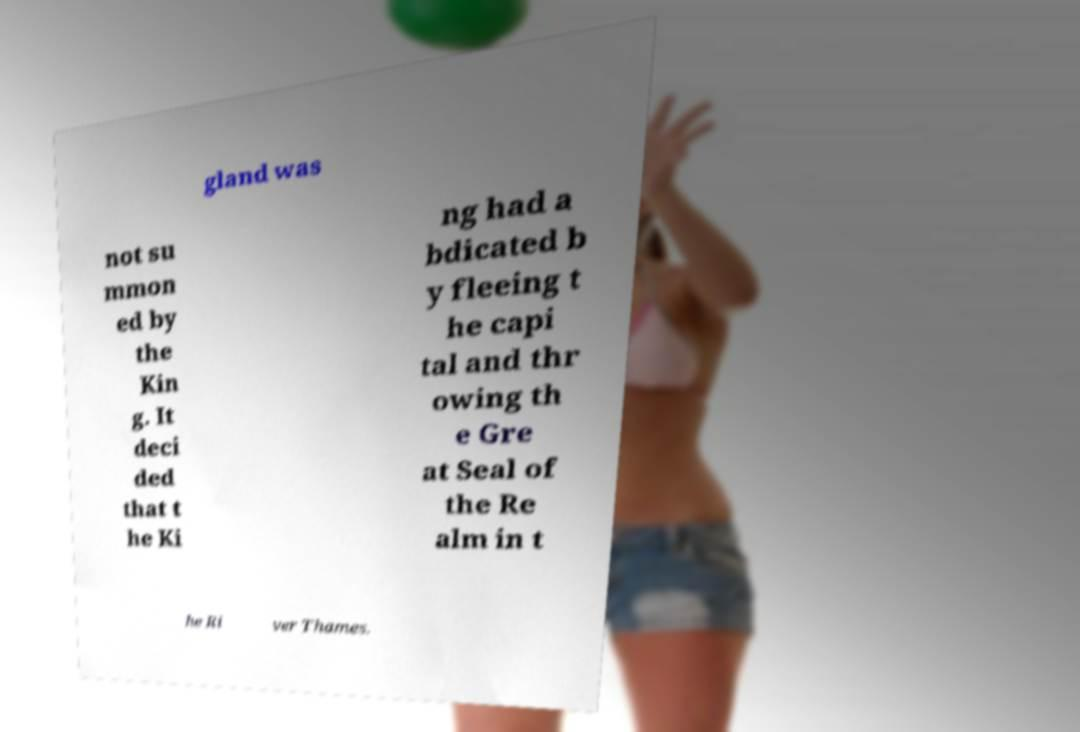Could you extract and type out the text from this image? gland was not su mmon ed by the Kin g. It deci ded that t he Ki ng had a bdicated b y fleeing t he capi tal and thr owing th e Gre at Seal of the Re alm in t he Ri ver Thames. 